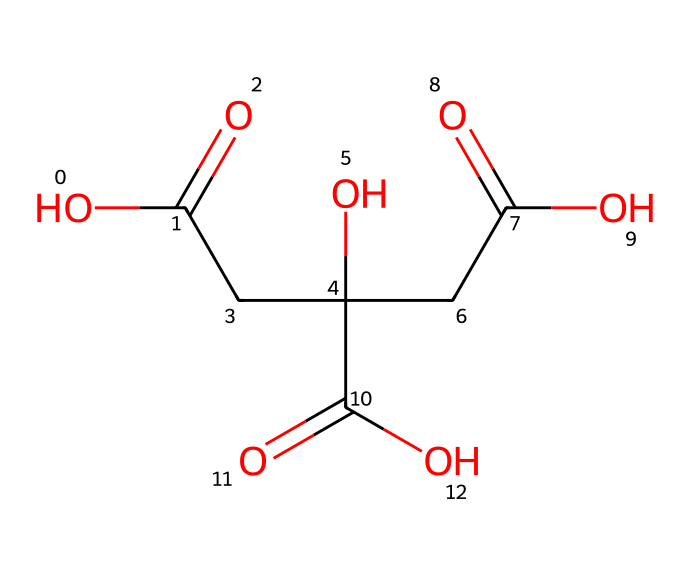What is the name of this chemical? This chemical is identified as citric acid, which is commonly found in citrus fruits and is used in various food and beverage products for flavor and preservation.
Answer: citric acid How many carbon atoms are present in this molecule? By examining the SMILES representation, we can count the carbon atoms (C) indicated in the structure. In this case, there are six carbon atoms in total.
Answer: six How many hydroxyl groups are present in citric acid? A hydroxyl group (-OH) can be identified by looking for the presence of oxygen bonded to hydrogen in the molecule. In this representation, there are three hydroxyl groups.
Answer: three What is the main property of citric acid in relation to pH? Citric acid is classified as a weak acid, which means it can donate protons and lower the pH of solutions, making them more acidic.
Answer: weak acid What type of acid is citric acid commonly classified as? Citric acid is typically classified as a tricarboxylic acid due to the presence of three carboxylic acid functional groups (-COOH) in its molecular structure.
Answer: tricarboxylic acid What role does citric acid play in sports drinks? In sports drinks, citric acid functions primarily as a flavoring agent and also helps in maintaining the stability and preservation of the drink, while contributing to electrolyte balance.
Answer: flavoring agent What determines the sour taste associated with citric acid? The sour taste of citric acid arises from the release of hydrogen ions (H+) when it dissociates in solution, which is a characteristic feature of acids that contributes to the perception of acidity or sourness.
Answer: hydrogen ions 